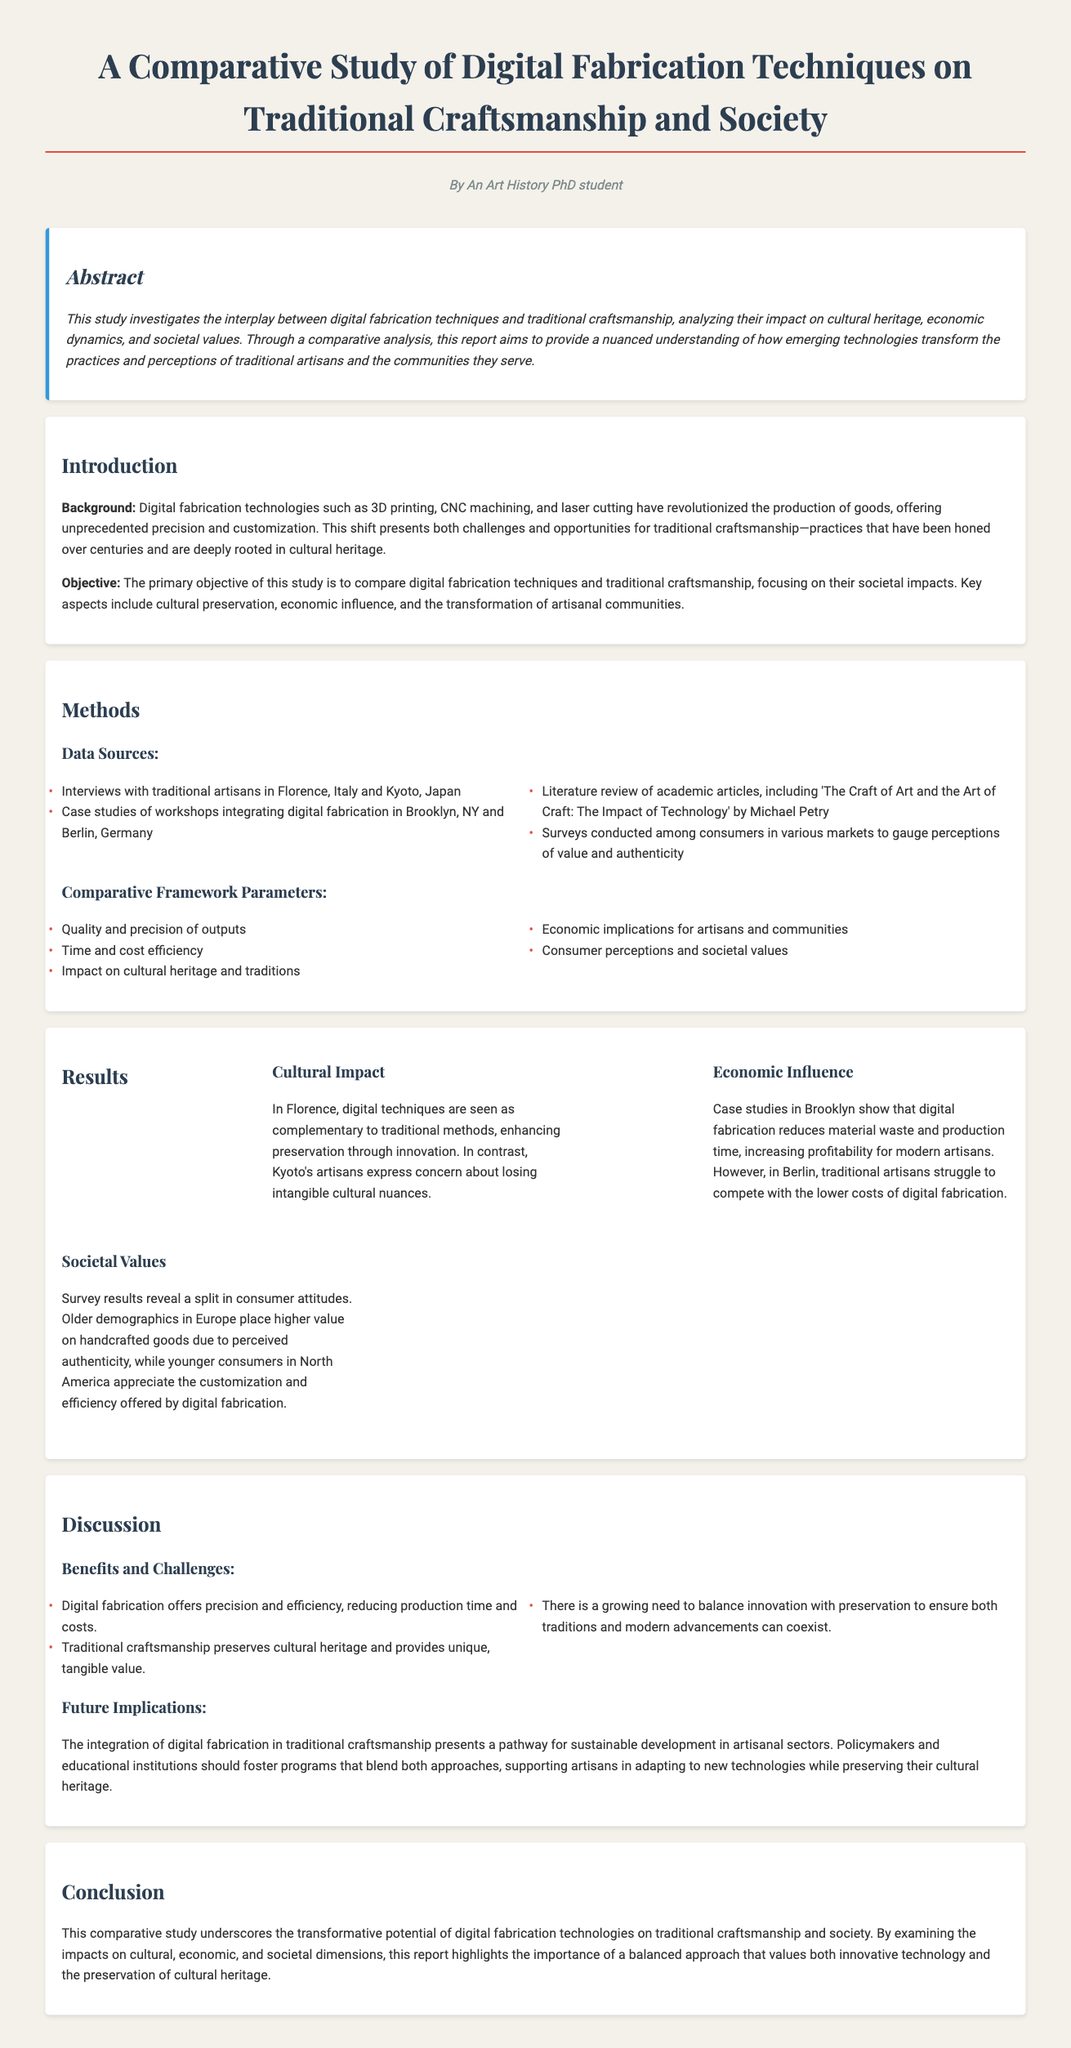What are the digital fabrication techniques mentioned? The document lists specific techniques such as 3D printing, CNC machining, and laser cutting under digital fabrication.
Answer: 3D printing, CNC machining, and laser cutting Who conducted interviews for the study? Interviews were conducted with traditional artisans from Florence and Kyoto, indicating the geographical focus of the study.
Answer: Traditional artisans in Florence, Italy and Kyoto, Japan What is the primary objective of the study? The document states that the primary objective is to compare digital fabrication techniques and traditional craftsmanship, focusing on societal impacts.
Answer: Compare digital fabrication techniques and traditional craftsmanship What is the split in consumer attitudes according to survey results? The survey results reveal a divide where older demographics value handcrafted goods, while younger consumers appreciate customization offered by digital fabrication.
Answer: Older demographics value handcrafted goods; younger consumers appreciate customization What are the benefits noted in the discussion? The benefits of digital fabrication and traditional craftsmanship listed include precision, efficiency, and preservation of cultural heritage.
Answer: Precision, efficiency, preservation of cultural heritage What city demonstrates economic influence positively related to digital fabrication? Case studies in Brooklyn indicate that digital fabrication increased profitability and efficiency in modern artisan practices.
Answer: Brooklyn, NY What do policymakers need to promote according to the future implications? The document suggests that policymakers should foster programs that blend innovation with preservation in artisanal sectors.
Answer: Programs that blend innovation with preservation What cultural concern do Kyoto's artisans express? Kyoto's artisans express concern about losing intangible cultural nuances in their traditional practices due to digital technologies.
Answer: Losing intangible cultural nuances 